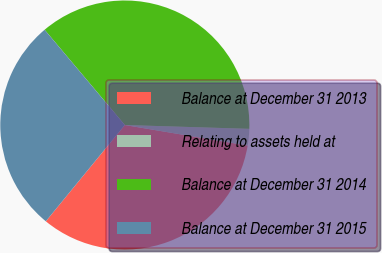Convert chart. <chart><loc_0><loc_0><loc_500><loc_500><pie_chart><fcel>Balance at December 31 2013<fcel>Relating to assets held at<fcel>Balance at December 31 2014<fcel>Balance at December 31 2015<nl><fcel>33.3%<fcel>2.15%<fcel>36.63%<fcel>27.93%<nl></chart> 